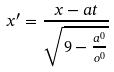Convert formula to latex. <formula><loc_0><loc_0><loc_500><loc_500>x ^ { \prime } = \frac { x - a t } { \sqrt { 9 - \frac { a ^ { 0 } } { o ^ { 0 } } } }</formula> 